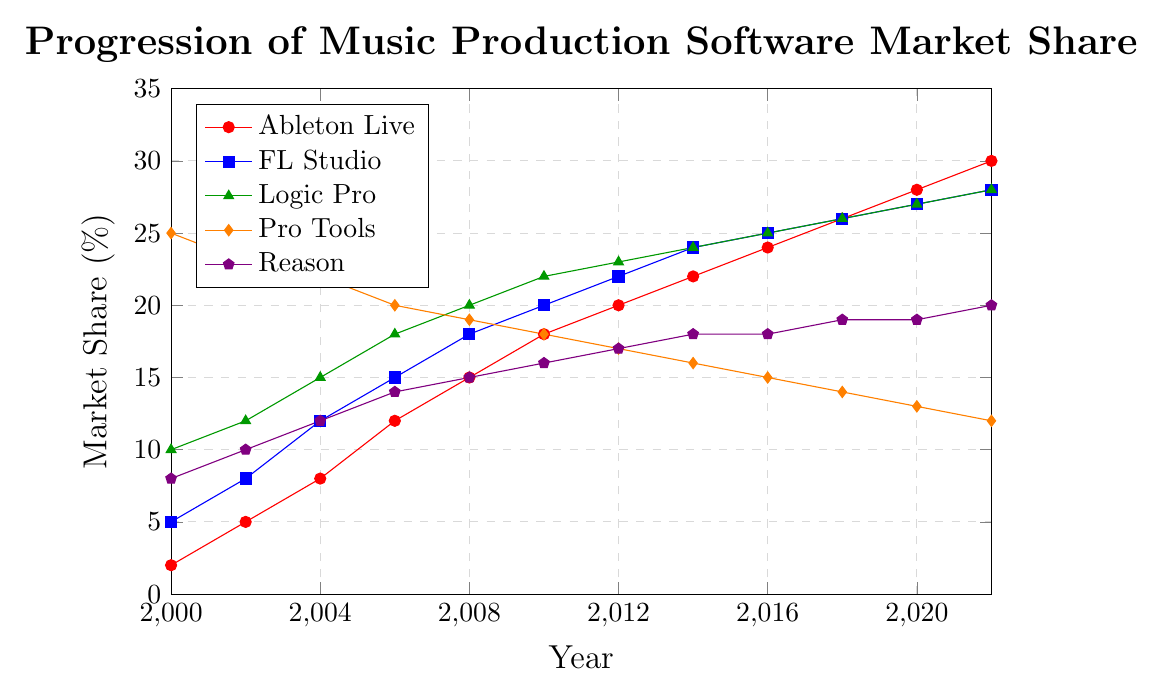Which software had the highest market share in 2000? In the year 2000, we look at the figures for each software and identify the highest value, which is Pro Tools with 25%.
Answer: Pro Tools Which software saw the most significant increase in market share from 2000 to 2022? Subtract the market share of each software in 2000 from its market share in 2022. Ableton Live increased from 2% to 30% (28%), FL Studio increased from 5% to 28% (23%), Logic Pro increased from 10% to 28% (18%), Pro Tools decreased from 25% to 12%, and Reason increased from 8% to 20% (12%). Ableton Live had the most significant increase of 28%.
Answer: Ableton Live Was there any software whose market share remained constant between any two consecutive data points? Look at the lines on the graph. Reason's market share remained unchanged from 2016 to 2020 at 18% and 19%, respectively.
Answer: Reason (2016-2018, 2018-2020) What is the average market share of Logic Pro from 2000 to 2022? Add up Logic Pro's market share values from 2000, 2002, 2004, 2006, 2008, 2010, 2012, 2014, 2016, 2018, 2020, and 2022, and divide by the number of years: (10+12+15+18+20+22+23+24+25+26+27+28)/12 = 22.25%.
Answer: 22.25% In 2022, how many software had a market share higher than 20%? Check the market share values for all software in 2022: Ableton Live (30%), FL Studio (28%), Logic Pro (28%), Pro Tools (12%), Reason (20%). Only three software have a market share higher than 20%: Ableton Live, FL Studio, and Logic Pro.
Answer: 3 Between Ableton Live and FL Studio, which had a higher market share in 2010, and by how much? Compare Ableton Live's market share (18%) and FL Studio's market share (20%) in 2010. The difference is 20% - 18% = 2%.
Answer: FL Studio by 2% Which software started with a higher market share in 2000, but had a lower market share than Ableton Live by 2022? Pro Tools started at 25% in 2000 and dropped to 12% in 2022, whereas Ableton Live increased to 30% by 2022.
Answer: Pro Tools 